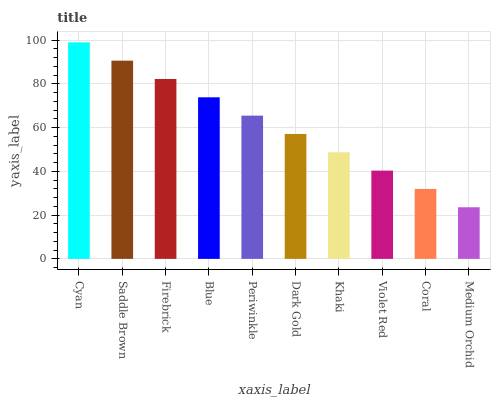Is Medium Orchid the minimum?
Answer yes or no. Yes. Is Cyan the maximum?
Answer yes or no. Yes. Is Saddle Brown the minimum?
Answer yes or no. No. Is Saddle Brown the maximum?
Answer yes or no. No. Is Cyan greater than Saddle Brown?
Answer yes or no. Yes. Is Saddle Brown less than Cyan?
Answer yes or no. Yes. Is Saddle Brown greater than Cyan?
Answer yes or no. No. Is Cyan less than Saddle Brown?
Answer yes or no. No. Is Periwinkle the high median?
Answer yes or no. Yes. Is Dark Gold the low median?
Answer yes or no. Yes. Is Cyan the high median?
Answer yes or no. No. Is Cyan the low median?
Answer yes or no. No. 